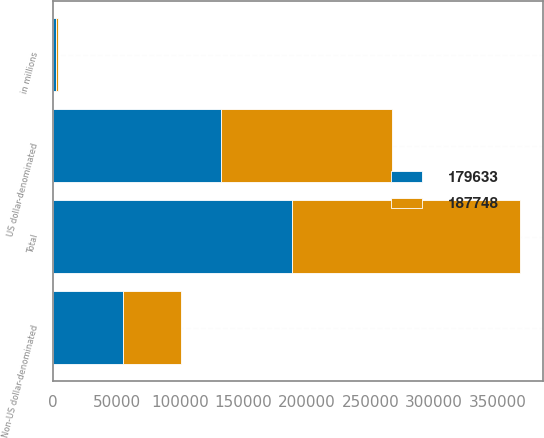Convert chart. <chart><loc_0><loc_0><loc_500><loc_500><stacked_bar_chart><ecel><fcel>in millions<fcel>US dollar-denominated<fcel>Non-US dollar-denominated<fcel>Total<nl><fcel>179633<fcel>2015<fcel>132415<fcel>55333<fcel>187748<nl><fcel>187748<fcel>2014<fcel>134223<fcel>45410<fcel>179633<nl></chart> 